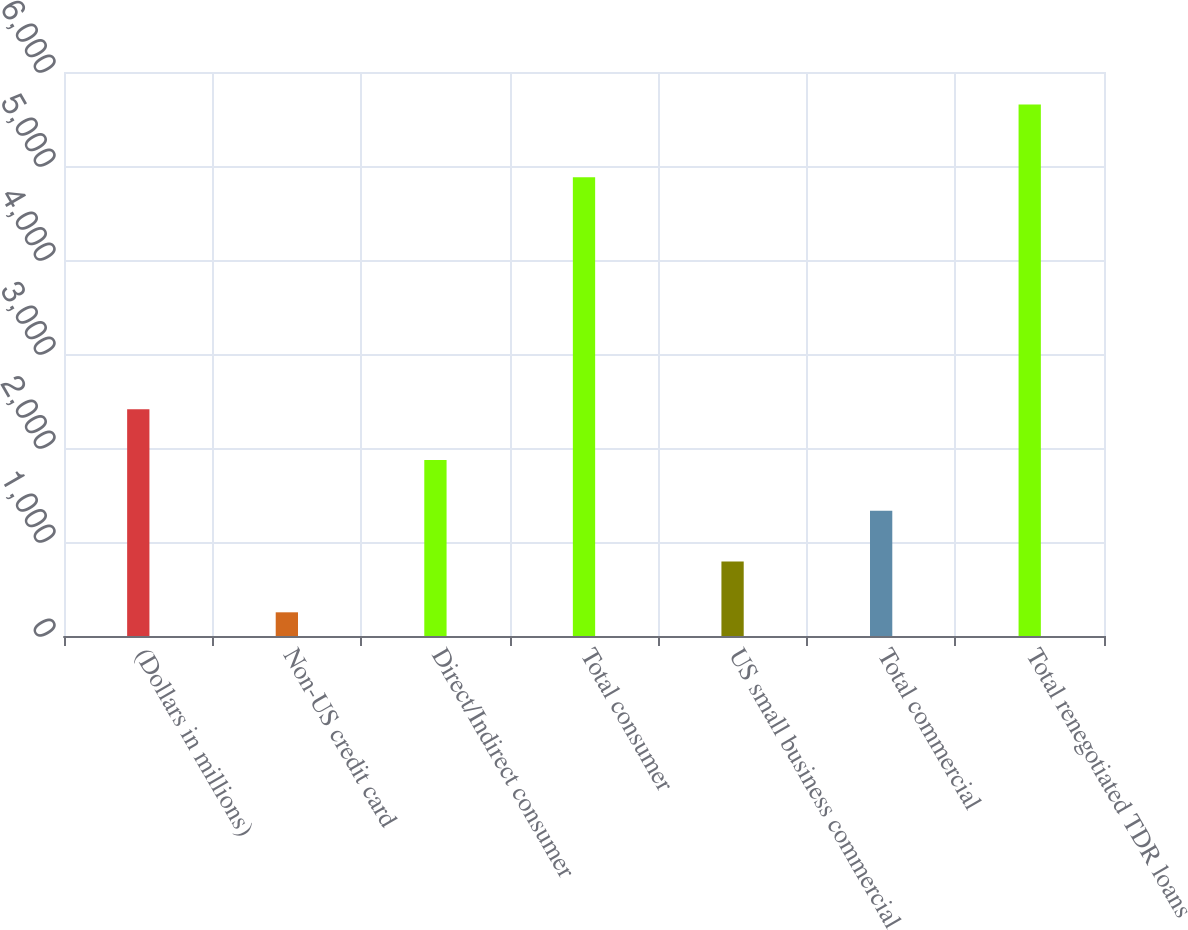Convert chart. <chart><loc_0><loc_0><loc_500><loc_500><bar_chart><fcel>(Dollars in millions)<fcel>Non-US credit card<fcel>Direct/Indirect consumer<fcel>Total consumer<fcel>US small business commercial<fcel>Total commercial<fcel>Total renegotiated TDR loans<nl><fcel>2413.2<fcel>252<fcel>1872.9<fcel>4879<fcel>792.3<fcel>1332.6<fcel>5655<nl></chart> 